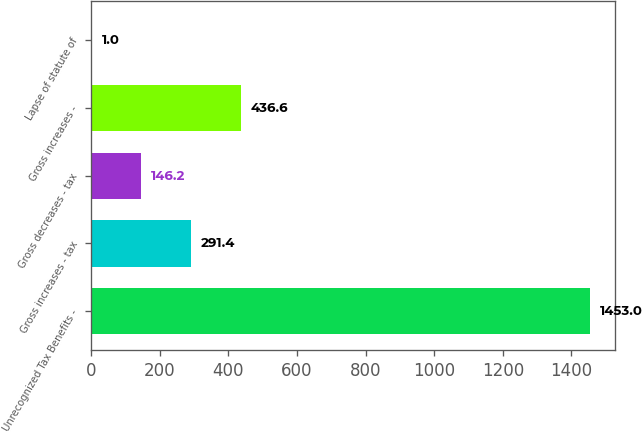Convert chart. <chart><loc_0><loc_0><loc_500><loc_500><bar_chart><fcel>Unrecognized Tax Benefits -<fcel>Gross increases - tax<fcel>Gross decreases - tax<fcel>Gross increases -<fcel>Lapse of statute of<nl><fcel>1453<fcel>291.4<fcel>146.2<fcel>436.6<fcel>1<nl></chart> 